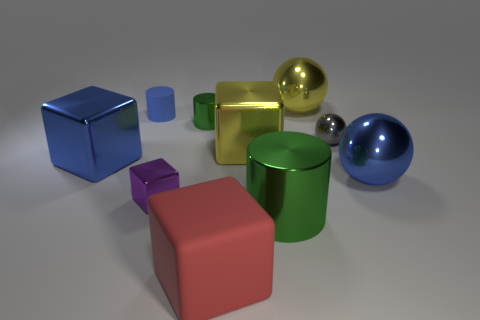There is a tiny rubber cylinder; is its color the same as the large thing left of the red rubber object?
Make the answer very short. Yes. What number of other things are the same material as the big red thing?
Keep it short and to the point. 1. The small purple thing that is the same material as the yellow sphere is what shape?
Keep it short and to the point. Cube. Is there any other thing that is the same color as the matte cube?
Give a very brief answer. No. The block that is the same color as the rubber cylinder is what size?
Ensure brevity in your answer.  Large. Is the number of metal spheres in front of the small shiny sphere greater than the number of big yellow rubber cylinders?
Your response must be concise. Yes. Do the tiny blue thing and the green thing that is to the left of the large green thing have the same shape?
Offer a terse response. Yes. What number of purple blocks are the same size as the matte cylinder?
Offer a very short reply. 1. What number of large blue shiny objects are behind the large metal cube behind the large blue object on the left side of the big green object?
Make the answer very short. 0. Are there the same number of large blue cubes on the right side of the yellow ball and small purple things that are in front of the large blue metallic ball?
Provide a succinct answer. No. 